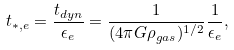Convert formula to latex. <formula><loc_0><loc_0><loc_500><loc_500>t _ { * , e } = \frac { t _ { d y n } } { \epsilon _ { e } } = \frac { 1 } { ( 4 \pi G \rho _ { g a s } ) ^ { 1 / 2 } } \frac { 1 } { \epsilon _ { e } } ,</formula> 